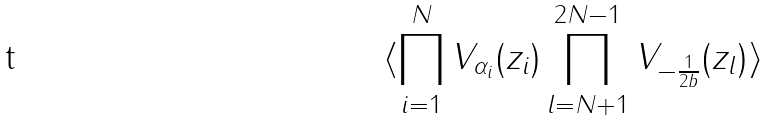<formula> <loc_0><loc_0><loc_500><loc_500>\langle \prod _ { i = 1 } ^ { N } V _ { \alpha _ { i } } ( z _ { i } ) \prod _ { l = N + 1 } ^ { 2 N - 1 } V _ { - \frac { 1 } { 2 b } } ( z _ { l } ) \rangle</formula> 